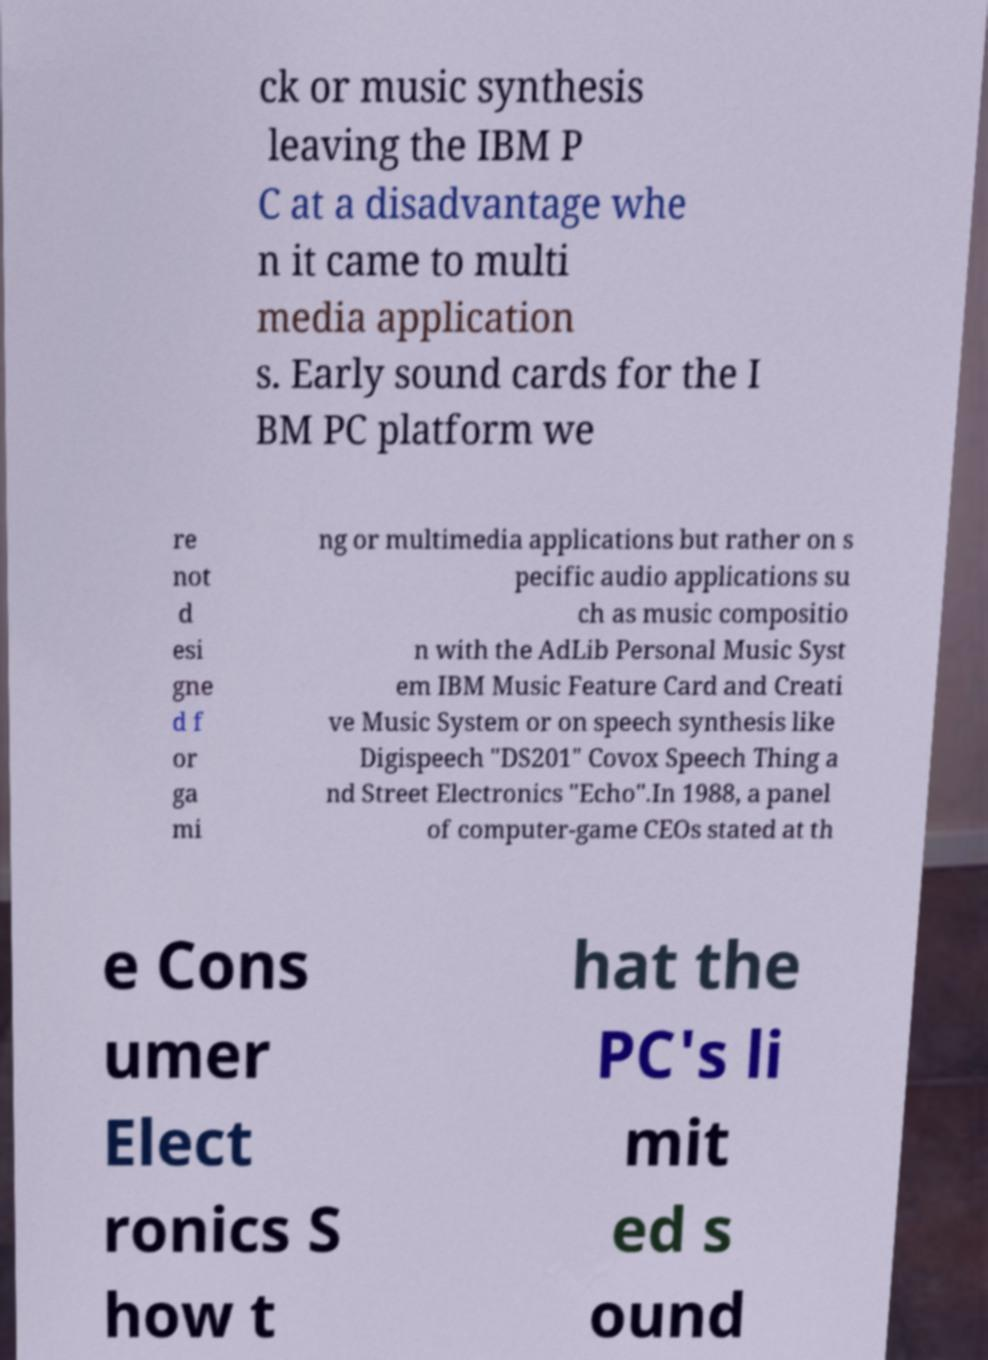For documentation purposes, I need the text within this image transcribed. Could you provide that? ck or music synthesis leaving the IBM P C at a disadvantage whe n it came to multi media application s. Early sound cards for the I BM PC platform we re not d esi gne d f or ga mi ng or multimedia applications but rather on s pecific audio applications su ch as music compositio n with the AdLib Personal Music Syst em IBM Music Feature Card and Creati ve Music System or on speech synthesis like Digispeech "DS201" Covox Speech Thing a nd Street Electronics "Echo".In 1988, a panel of computer-game CEOs stated at th e Cons umer Elect ronics S how t hat the PC's li mit ed s ound 